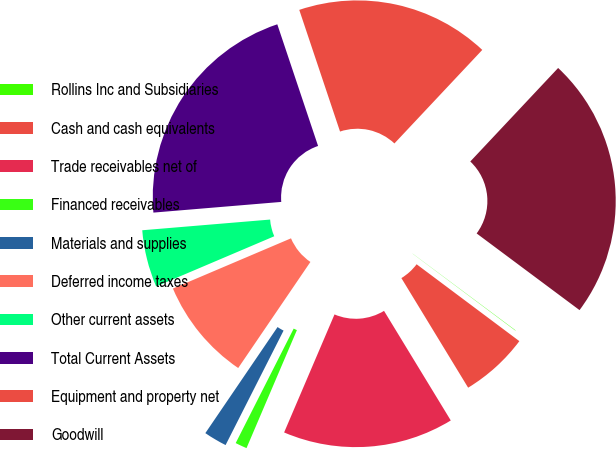<chart> <loc_0><loc_0><loc_500><loc_500><pie_chart><fcel>Rollins Inc and Subsidiaries<fcel>Cash and cash equivalents<fcel>Trade receivables net of<fcel>Financed receivables<fcel>Materials and supplies<fcel>Deferred income taxes<fcel>Other current assets<fcel>Total Current Assets<fcel>Equipment and property net<fcel>Goodwill<nl><fcel>0.03%<fcel>6.07%<fcel>15.13%<fcel>1.04%<fcel>2.05%<fcel>9.09%<fcel>5.07%<fcel>21.18%<fcel>17.15%<fcel>23.19%<nl></chart> 